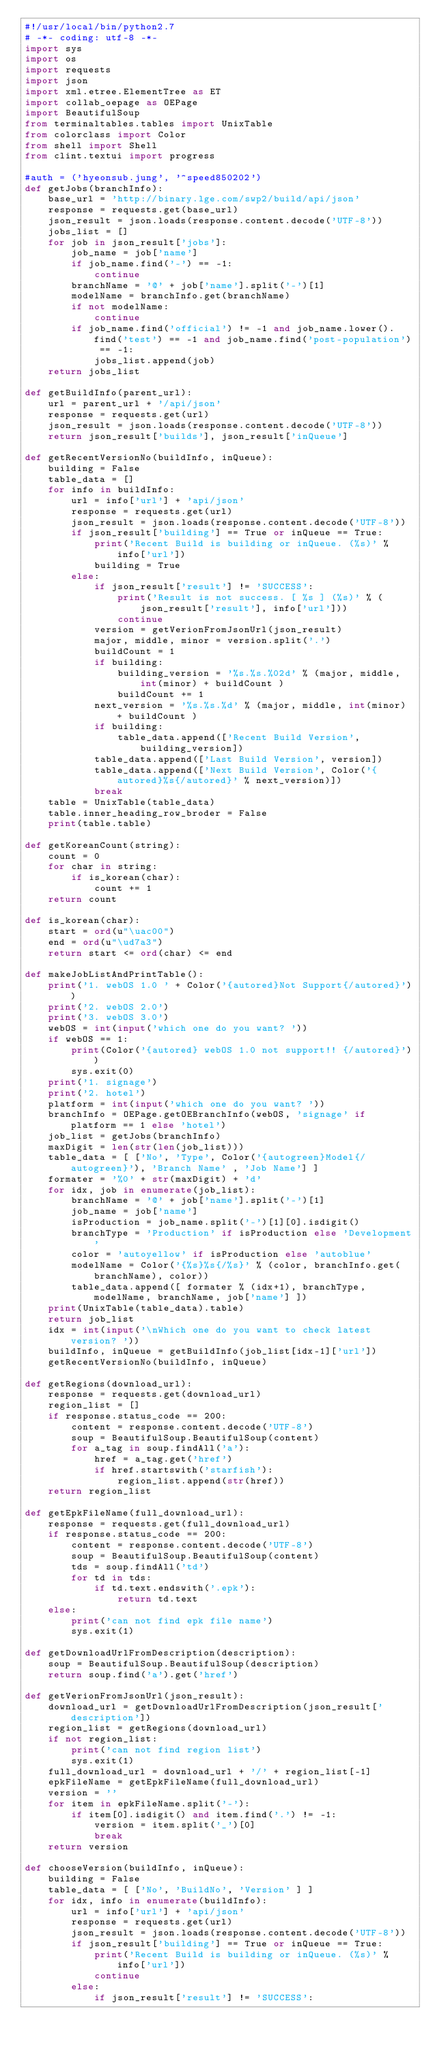Convert code to text. <code><loc_0><loc_0><loc_500><loc_500><_Python_>#!/usr/local/bin/python2.7
# -*- coding: utf-8 -*-
import sys
import os
import requests
import json
import xml.etree.ElementTree as ET
import collab_oepage as OEPage
import BeautifulSoup
from terminaltables.tables import UnixTable
from colorclass import Color
from shell import Shell
from clint.textui import progress

#auth = ('hyeonsub.jung', '^speed850202')
def getJobs(branchInfo):
    base_url = 'http://binary.lge.com/swp2/build/api/json'
    response = requests.get(base_url)
    json_result = json.loads(response.content.decode('UTF-8'))
    jobs_list = []
    for job in json_result['jobs']:
        job_name = job['name']
        if job_name.find('-') == -1:
            continue
        branchName = '@' + job['name'].split('-')[1]
        modelName = branchInfo.get(branchName)
        if not modelName:
            continue
        if job_name.find('official') != -1 and job_name.lower().find('test') == -1 and job_name.find('post-population') == -1:
            jobs_list.append(job)
    return jobs_list

def getBuildInfo(parent_url):
    url = parent_url + '/api/json'
    response = requests.get(url)
    json_result = json.loads(response.content.decode('UTF-8'))
    return json_result['builds'], json_result['inQueue']

def getRecentVersionNo(buildInfo, inQueue):
    building = False
    table_data = []
    for info in buildInfo:
        url = info['url'] + 'api/json'
        response = requests.get(url)
        json_result = json.loads(response.content.decode('UTF-8'))
        if json_result['building'] == True or inQueue == True:
            print('Recent Build is building or inQueue. (%s)' % info['url'])
            building = True
        else:
            if json_result['result'] != 'SUCCESS':
                print('Result is not success. [ %s ] (%s)' % (json_result['result'], info['url']))
                continue
            version = getVerionFromJsonUrl(json_result)
            major, middle, minor = version.split('.')
            buildCount = 1
            if building:
                building_version = '%s.%s.%02d' % (major, middle, int(minor) + buildCount )
                buildCount += 1
            next_version = '%s.%s.%d' % (major, middle, int(minor) + buildCount )
            if building:
                table_data.append(['Recent Build Version', building_version])
            table_data.append(['Last Build Version', version])
            table_data.append(['Next Build Version', Color('{autored}%s{/autored}' % next_version)])
            break
    table = UnixTable(table_data)
    table.inner_heading_row_broder = False
    print(table.table)

def getKoreanCount(string):
    count = 0
    for char in string:
        if is_korean(char):
            count += 1
    return count

def is_korean(char):
    start = ord(u"\uac00")
    end = ord(u"\ud7a3")
    return start <= ord(char) <= end

def makeJobListAndPrintTable():
    print('1. webOS 1.0 ' + Color('{autored}Not Support{/autored}'))
    print('2. webOS 2.0')
    print('3. webOS 3.0')
    webOS = int(input('which one do you want? '))
    if webOS == 1:
        print(Color('{autored} webOS 1.0 not support!! {/autored}'))
        sys.exit(0)
    print('1. signage')
    print('2. hotel')
    platform = int(input('which one do you want? '))
    branchInfo = OEPage.getOEBranchInfo(webOS, 'signage' if platform == 1 else 'hotel')
    job_list = getJobs(branchInfo)
    maxDigit = len(str(len(job_list)))
    table_data = [ ['No', 'Type', Color('{autogreen}Model{/autogreen}'), 'Branch Name' , 'Job Name'] ]
    formater = '%0' + str(maxDigit) + 'd'
    for idx, job in enumerate(job_list):
        branchName = '@' + job['name'].split('-')[1]
        job_name = job['name']
        isProduction = job_name.split('-')[1][0].isdigit()
        branchType = 'Production' if isProduction else 'Development'
        color = 'autoyellow' if isProduction else 'autoblue'
        modelName = Color('{%s}%s{/%s}' % (color, branchInfo.get(branchName), color))
        table_data.append([ formater % (idx+1), branchType, modelName, branchName, job['name'] ])
    print(UnixTable(table_data).table)
    return job_list
    idx = int(input('\nWhich one do you want to check latest version? '))
    buildInfo, inQueue = getBuildInfo(job_list[idx-1]['url'])
    getRecentVersionNo(buildInfo, inQueue)

def getRegions(download_url):
    response = requests.get(download_url)
    region_list = []
    if response.status_code == 200:
        content = response.content.decode('UTF-8')
        soup = BeautifulSoup.BeautifulSoup(content)
        for a_tag in soup.findAll('a'):
            href = a_tag.get('href')
            if href.startswith('starfish'):
                region_list.append(str(href))
    return region_list

def getEpkFileName(full_download_url):
    response = requests.get(full_download_url)
    if response.status_code == 200:
        content = response.content.decode('UTF-8')
        soup = BeautifulSoup.BeautifulSoup(content)
        tds = soup.findAll('td')
        for td in tds:
            if td.text.endswith('.epk'):
                return td.text
    else:
        print('can not find epk file name')
        sys.exit(1)

def getDownloadUrlFromDescription(description):
    soup = BeautifulSoup.BeautifulSoup(description)
    return soup.find('a').get('href')

def getVerionFromJsonUrl(json_result):
    download_url = getDownloadUrlFromDescription(json_result['description'])
    region_list = getRegions(download_url)
    if not region_list:
        print('can not find region list')
        sys.exit(1)
    full_download_url = download_url + '/' + region_list[-1]
    epkFileName = getEpkFileName(full_download_url)
    version = ''
    for item in epkFileName.split('-'):
        if item[0].isdigit() and item.find('.') != -1:
            version = item.split('_')[0]
            break
    return version

def chooseVersion(buildInfo, inQueue):
    building = False
    table_data = [ ['No', 'BuildNo', 'Version' ] ]
    for idx, info in enumerate(buildInfo):
        url = info['url'] + 'api/json'
        response = requests.get(url)
        json_result = json.loads(response.content.decode('UTF-8'))
        if json_result['building'] == True or inQueue == True:
            print('Recent Build is building or inQueue. (%s)' % info['url'])
            continue
        else:
            if json_result['result'] != 'SUCCESS':</code> 